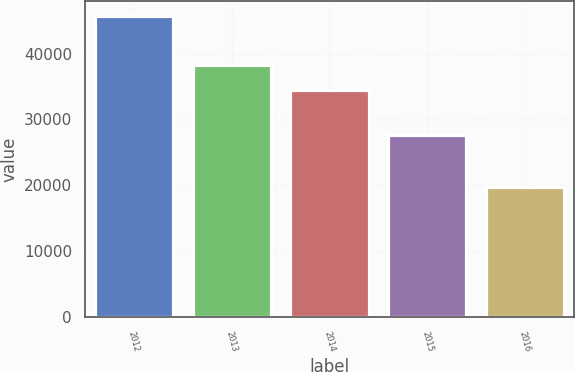Convert chart to OTSL. <chart><loc_0><loc_0><loc_500><loc_500><bar_chart><fcel>2012<fcel>2013<fcel>2014<fcel>2015<fcel>2016<nl><fcel>45712<fcel>38346<fcel>34434<fcel>27625<fcel>19690<nl></chart> 